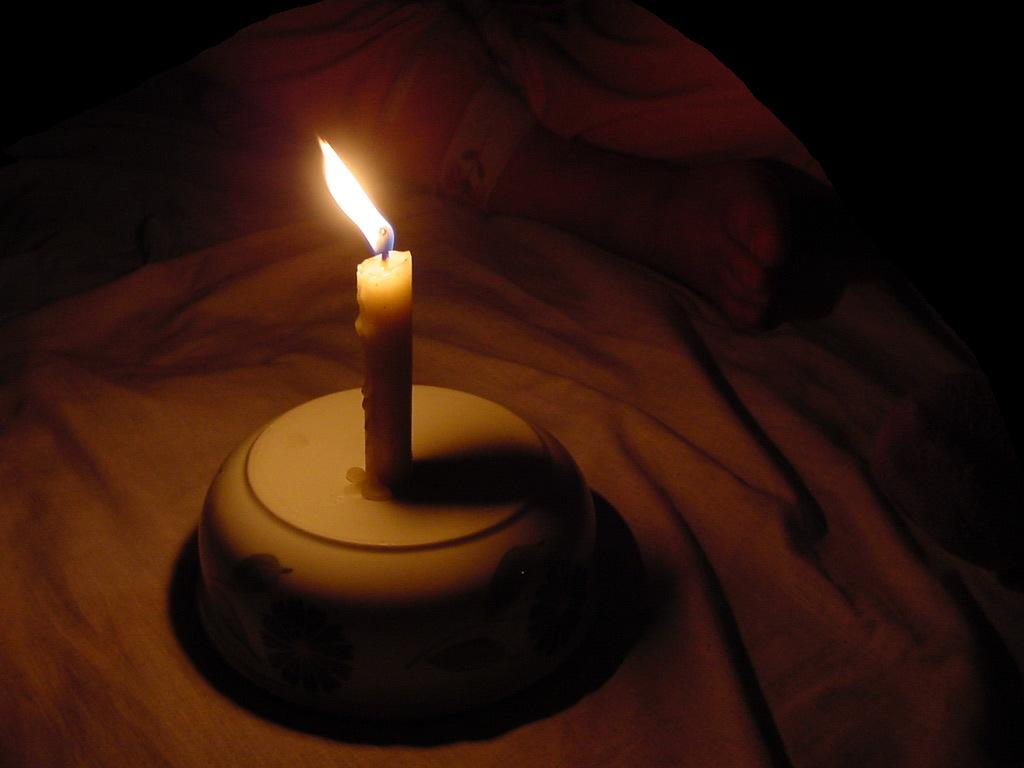What object in the image is providing light? The candle in the image is lit and providing light. What is the candle placed on? The candle is placed on a bowl. Can you describe any part of a person visible in the image? Yes, there is a person's leg visible in the image. How many babies are on the list in the image? There is no list or babies present in the image. What is the person's health status in the image? The provided facts do not give any information about the person's health status. 